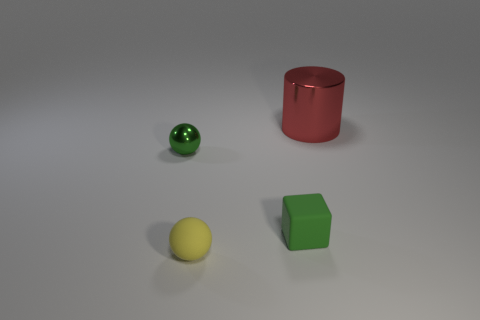Is there a shiny object that is left of the tiny sphere that is behind the yellow sphere?
Your answer should be very brief. No. Is there any other thing that has the same color as the small shiny ball?
Give a very brief answer. Yes. Does the sphere to the left of the yellow matte ball have the same material as the block?
Provide a succinct answer. No. Are there an equal number of tiny rubber cubes that are on the left side of the green rubber object and small metallic objects in front of the big red cylinder?
Make the answer very short. No. There is a object that is behind the green thing behind the small rubber cube; how big is it?
Make the answer very short. Large. What is the material of the object that is in front of the metallic cylinder and right of the yellow sphere?
Keep it short and to the point. Rubber. How many other objects are there of the same size as the block?
Provide a short and direct response. 2. What color is the cylinder?
Your answer should be compact. Red. There is a small thing that is behind the block; is its color the same as the metal thing that is on the right side of the tiny yellow ball?
Provide a succinct answer. No. What is the size of the rubber block?
Give a very brief answer. Small. 